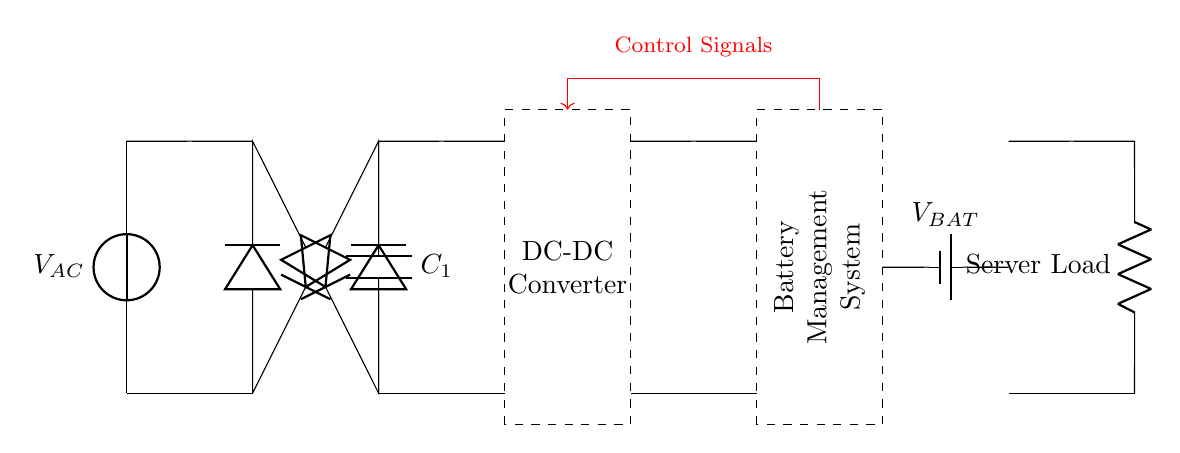What is the power source in this circuit? The power source is labeled as V_AC, which indicates it is an alternating current voltage source.
Answer: V_AC What component is used for rectification in this circuit? There are four diodes arranged in the circuit, which together act as a rectifier to convert alternating current to direct current.
Answer: Diode What is the role of C1 in this circuit? Capacitor C1 is used for smoothing the output voltage after rectification, helping to reduce fluctuations in the voltage.
Answer: Smoothing Which component manages the battery charging and discharging? The Battery Management System is responsible for managing the charging and discharging processes of the battery in the circuit.
Answer: Battery Management System How does the control system interact with the DC-DC converter? Control signals move from the battery management system, directing the operation of the DC-DC converter to regulate output voltage and battery operation.
Answer: Control Signals What type of load is depicted in this circuit? The load in this circuit is labeled simply as "Server Load," indicating it is specifically designed to supply power to a server.
Answer: Server Load How can the battery voltage be identified in the circuit? The battery is labeled as V_BAT, which specifies its voltage level as indicated in the schematic, making it easy to identify.
Answer: V_BAT 